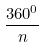Convert formula to latex. <formula><loc_0><loc_0><loc_500><loc_500>\frac { 3 6 0 ^ { 0 } } { n }</formula> 